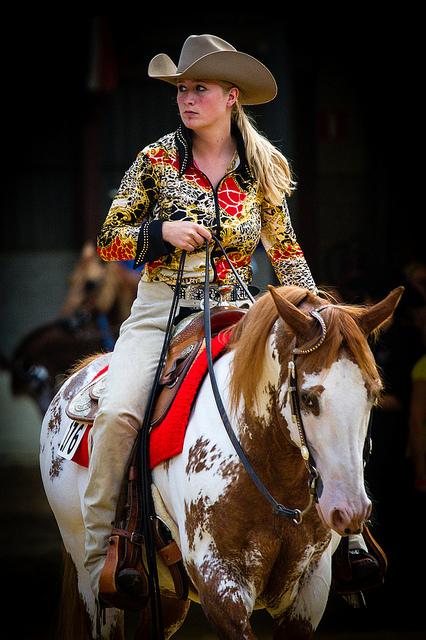How many horses are there?
Answer briefly. 1. Is the woman wearing traditional riding boots?
Be succinct. No. What is the girl riding?
Keep it brief. Horse. Does the horse have freckles?
Keep it brief. Yes. What is the woman wearing on her arm?
Concise answer only. Shirt. Are her shoes typical of what a cowgirl would wear?
Be succinct. Yes. 